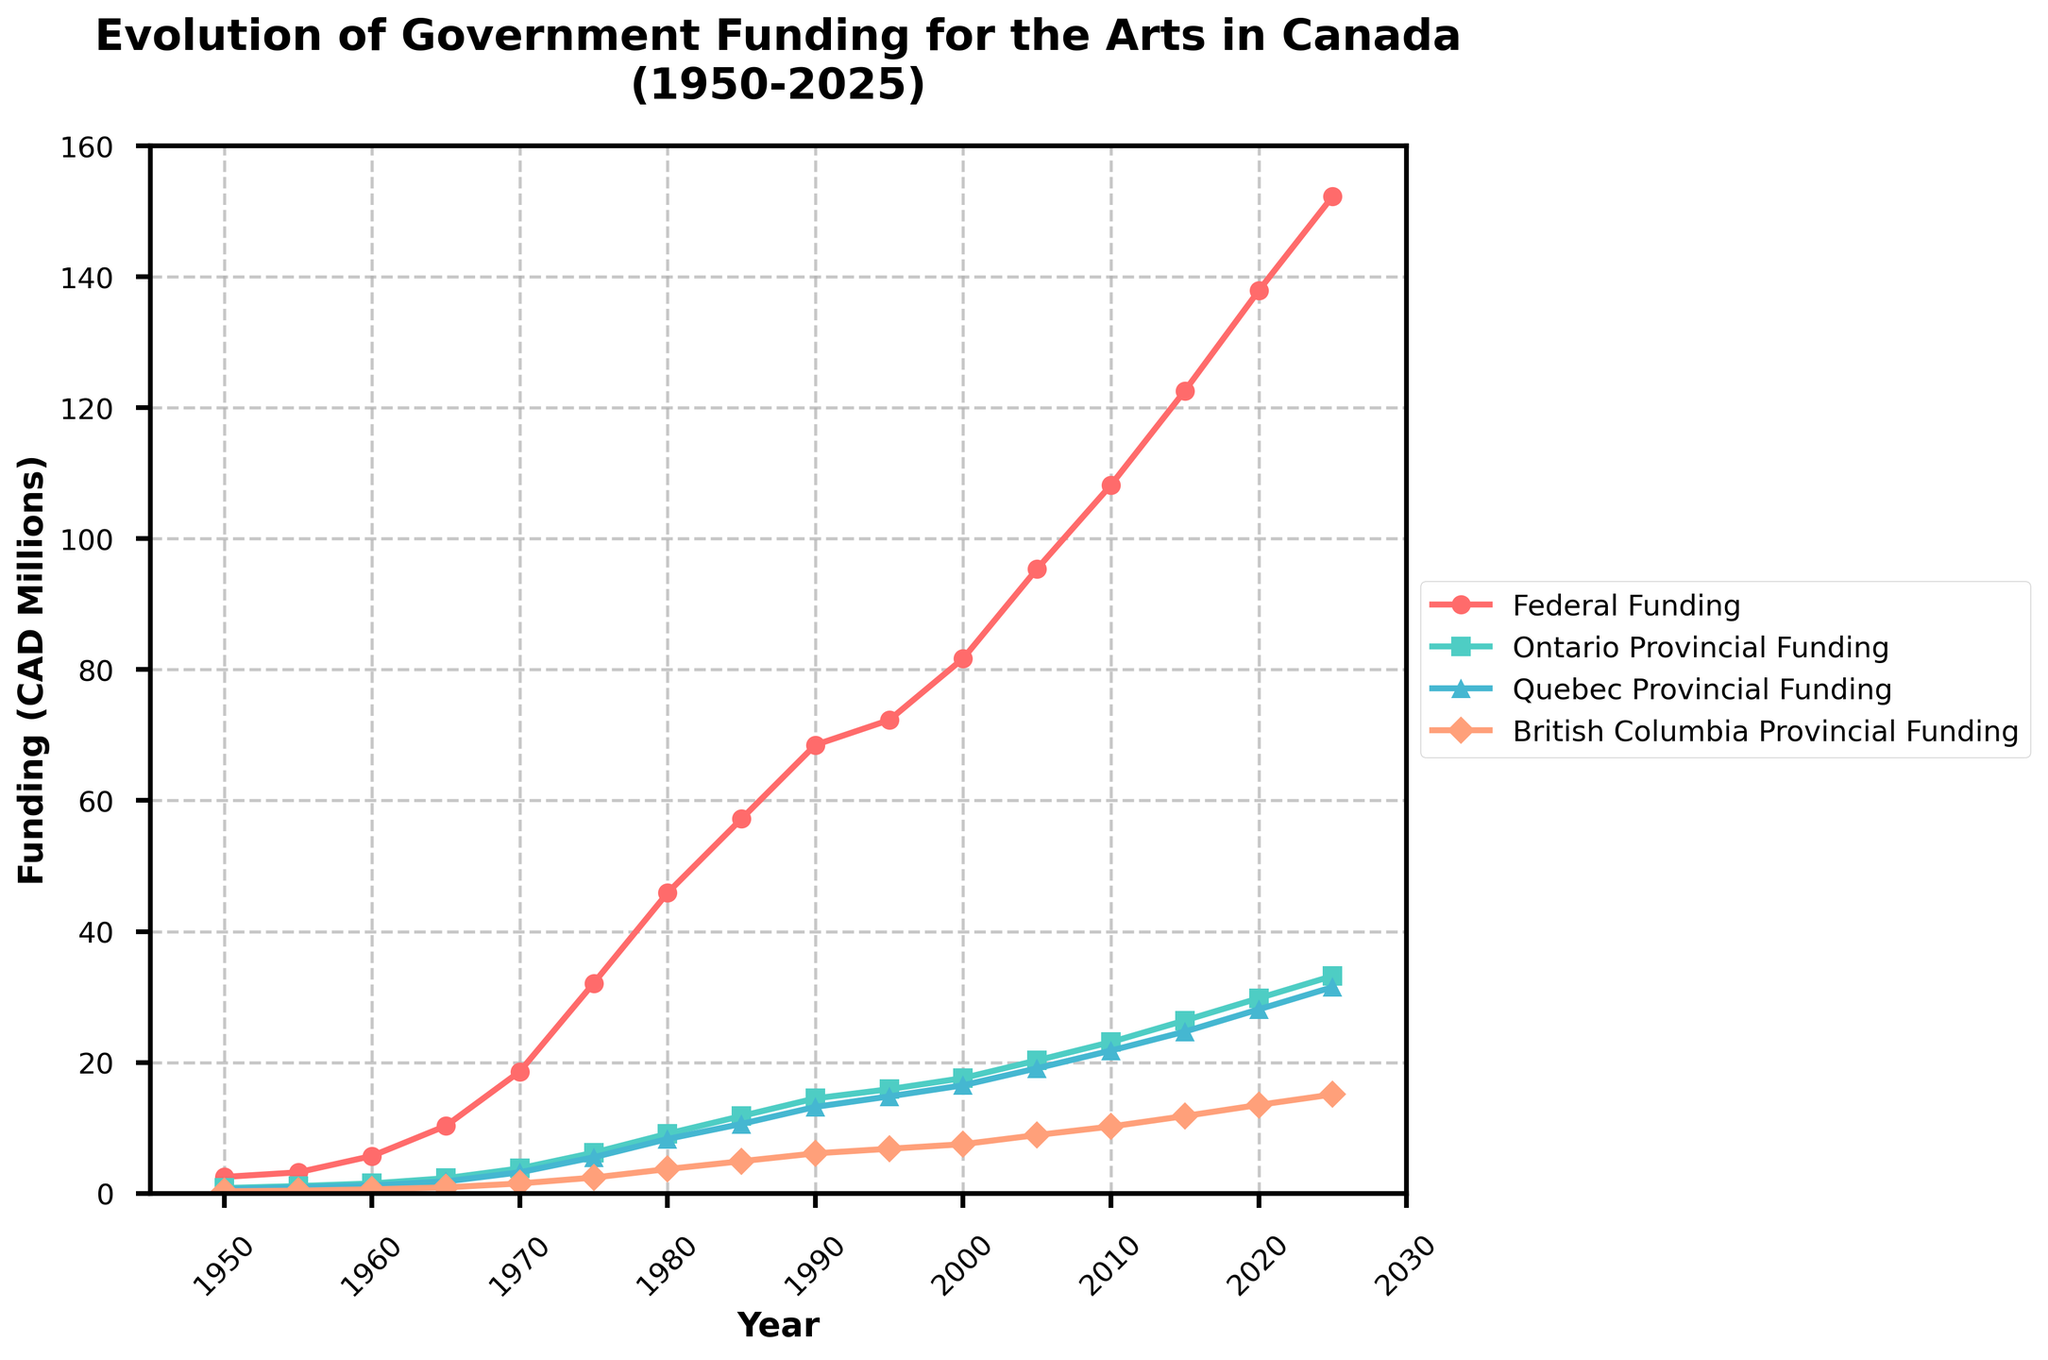What is the trend of federal funding for the arts from 1950 to 2025? The federal funding for the arts has shown a consistently increasing trend from 1950 to 2025. It started at 2.5 million CAD in 1950 and reaches 152.3 million CAD by 2025. This indicates a significant and steady growth over the years.
Answer: Increasing trend Which province had the highest provincial funding for the arts in 2025? In 2025, the plot indicates that Ontario had the highest provincial funding for the arts with 33.2 million CAD, compared to Quebec's 31.5 million CAD and British Columbia's 15.1 million CAD.
Answer: Ontario By how much did Quebec's provincial funding for the arts increase from 1950 to 2025? Quebec's provincial funding for the arts increased from 0.6 million CAD in 1950 to 31.5 million CAD in 2025. The increase can be calculated as follows: 31.5 - 0.6 = 30.9 million CAD.
Answer: 30.9 million CAD Between which years did federal funding for the arts see the largest absolute increase? To determine this, examine the plot and calculate the differences between adjacent years. The largest increase appears to be between 1965 and 1970, where federal funding increased from 10.3 million CAD to 18.6 million CAD. The absolute increase is 18.6 - 10.3 = 8.3 million CAD.
Answer: 1965 to 1970 What is the total funding (federal plus the three provincial) in 2005? Adding the funding amounts for 2005: Federal (95.4 million CAD) + Ontario (20.3 million CAD) + Quebec (19.1 million CAD) + British Columbia (8.9 million CAD) yields a total: 95.4 + 20.3 + 19.1 + 8.9 = 143.7 million CAD.
Answer: 143.7 million CAD How does the growth rate of federal funding for the arts compare to Ontario’s provincial funding from 1950 to 2025? To compare the growth rates, examine the initial and final amounts. Federal funding grew from 2.5 million CAD to 152.3 million CAD, and Ontario's funding grew from 0.8 million CAD to 33.2 million CAD. The growth factors are: Federal: 152.3 / 2.5 ≈ 61; Ontario: 33.2 / 0.8 ≈ 41. The federal funding grew at a proportionately higher rate than Ontario's funding.
Answer: Federal growth higher What is the difference between Ontario and Quebec provincial funding in 2020? In 2020, Ontario's funding was 29.8 million CAD and Quebec's was 28.1 million CAD. The difference is: 29.8 - 28.1 = 1.7 million CAD.
Answer: 1.7 million CAD Which type of funding shows the smallest increase from 1995 to 2000? To determine this, compare the increases for each type of funding between these years: Federal: 81.7 - 72.3 = 9.4 million CAD; Ontario: 17.6 - 15.9 = 1.7 million CAD; Quebec: 16.5 - 14.8 = 1.7 million CAD; British Columbia: 7.5 - 6.8 = 0.7 million CAD. British Columbia has the smallest increase.
Answer: British Columbia Compare provincial funding trends for Quebec and British Columbia from 1950 to 2025. Both Quebec and British Columbia show an increasing trend in their provincial funding. However, Quebec's funding starts at 0.6 million CAD and reaches 31.5 million CAD, whereas British Columbia’s starts at 0.3 million CAD and reaches 15.1 million CAD. Quebec has higher growth both in absolute and relative terms.
Answer: Quebec is higher 